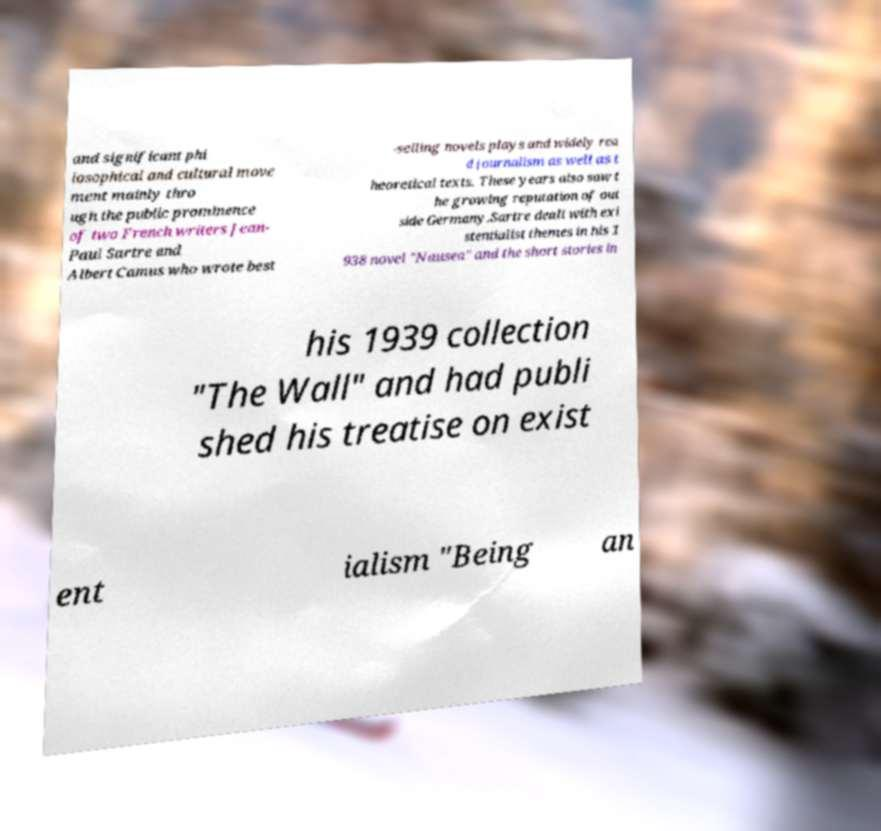I need the written content from this picture converted into text. Can you do that? and significant phi losophical and cultural move ment mainly thro ugh the public prominence of two French writers Jean- Paul Sartre and Albert Camus who wrote best -selling novels plays and widely rea d journalism as well as t heoretical texts. These years also saw t he growing reputation of out side Germany.Sartre dealt with exi stentialist themes in his 1 938 novel "Nausea" and the short stories in his 1939 collection "The Wall" and had publi shed his treatise on exist ent ialism "Being an 